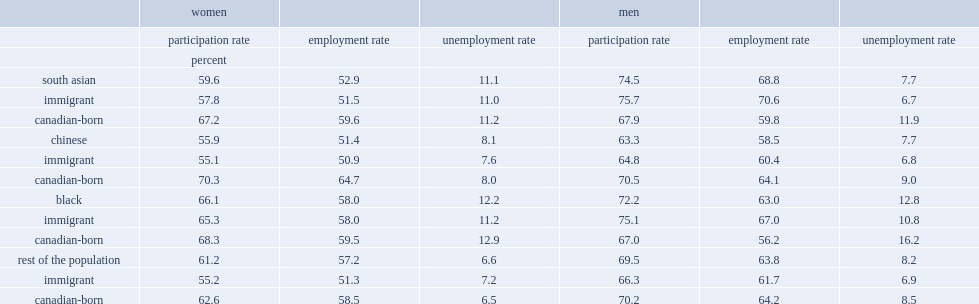I'm looking to parse the entire table for insights. Could you assist me with that? {'header': ['', 'women', '', '', 'men', '', ''], 'rows': [['', 'participation rate', 'employment rate', 'unemployment rate', 'participation rate', 'employment rate', 'unemployment rate'], ['', 'percent', '', '', '', '', ''], ['south asian', '59.6', '52.9', '11.1', '74.5', '68.8', '7.7'], ['immigrant', '57.8', '51.5', '11.0', '75.7', '70.6', '6.7'], ['canadian-born', '67.2', '59.6', '11.2', '67.9', '59.8', '11.9'], ['chinese', '55.9', '51.4', '8.1', '63.3', '58.5', '7.7'], ['immigrant', '55.1', '50.9', '7.6', '64.8', '60.4', '6.8'], ['canadian-born', '70.3', '64.7', '8.0', '70.5', '64.1', '9.0'], ['black', '66.1', '58.0', '12.2', '72.2', '63.0', '12.8'], ['immigrant', '65.3', '58.0', '11.2', '75.1', '67.0', '10.8'], ['canadian-born', '68.3', '59.5', '12.9', '67.0', '56.2', '16.2'], ['rest of the population', '61.2', '57.2', '6.6', '69.5', '63.8', '8.2'], ['immigrant', '55.2', '51.3', '7.2', '66.3', '61.7', '6.9'], ['canadian-born', '62.6', '58.5', '6.5', '70.2', '64.2', '8.5']]} Whose unemployment rate was higher in 2016, canadian-born black women or immigrant black women? Canadian-born. Among south asian men, whose participation rate was higher, immigrant men or their canadian-born counterparts? Immigrant. Among black men, whose participation rate was higher, immigrant men or their canadian-born counterparts? Immigrant. Among chinese men, whose participation rate was lower, immigrant men or their canadian-born counterparts? Immigrant. Among other men, whose participation rate was lower, immigrant men or their canadian-born counterparts? Immigrant. Among south asian men, whose employment rate was higher, immigrant men or their canadian-born counterparts? Immigrant. Among black men, whose employment rate was higher, immigrant men or their canadian-born counterparts? Immigrant. Among chinese men, whose employment rate was lower, immigrant men or their canadian-born counterparts? Immigrant. Among other men, whose employment rate was lower, immigrant men or their canadian-born counterparts? Immigrant. 